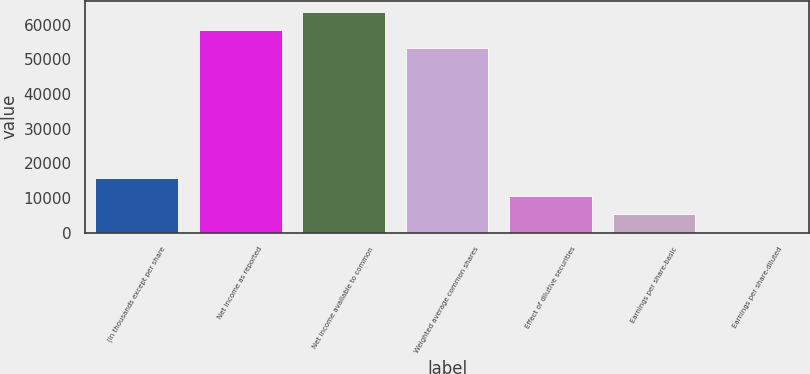<chart> <loc_0><loc_0><loc_500><loc_500><bar_chart><fcel>(In thousands except per share<fcel>Net income as reported<fcel>Net income available to common<fcel>Weighted average common shares<fcel>Effect of dilutive securities<fcel>Earnings per share-basic<fcel>Earnings per share-diluted<nl><fcel>15768.1<fcel>58532.4<fcel>63788.1<fcel>53276.7<fcel>10512.4<fcel>5256.74<fcel>1.05<nl></chart> 